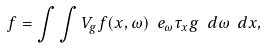<formula> <loc_0><loc_0><loc_500><loc_500>f = \int \int V _ { g } f ( x , \omega ) \ e _ { \omega } \tau _ { x } g \ d \omega \ d x ,</formula> 